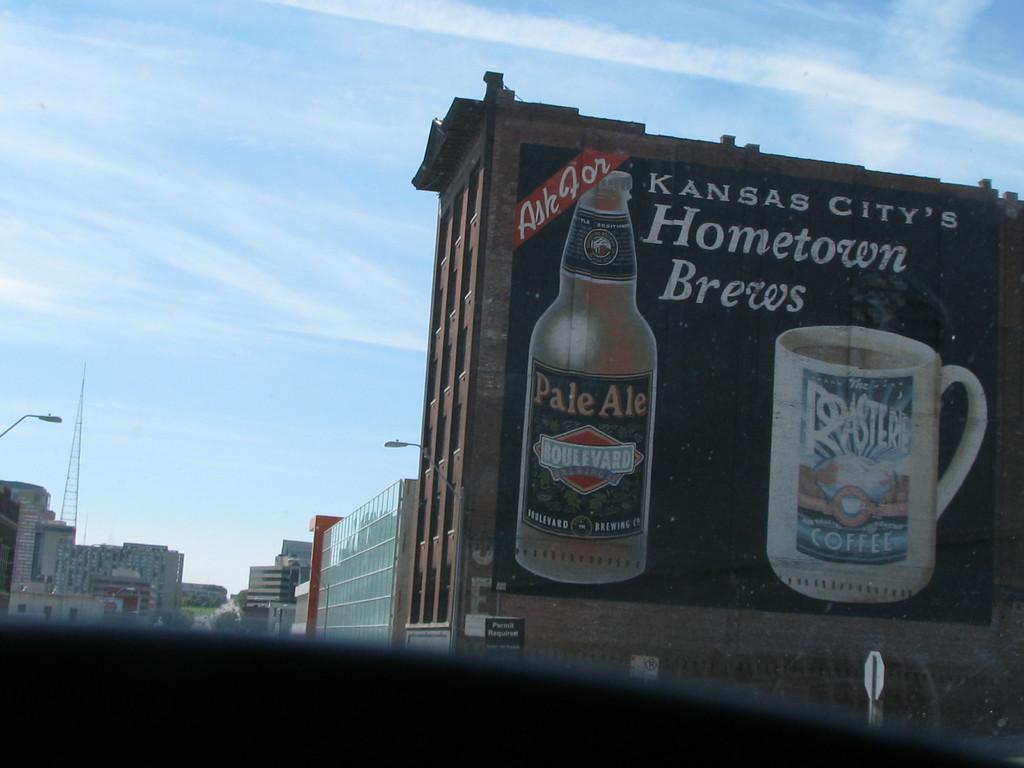How would you summarize this image in a sentence or two? In this image we can see many buildings. On the building there is an advertisement. On that there is a bottle and cup. In the back there is a tower and sky with clouds. 